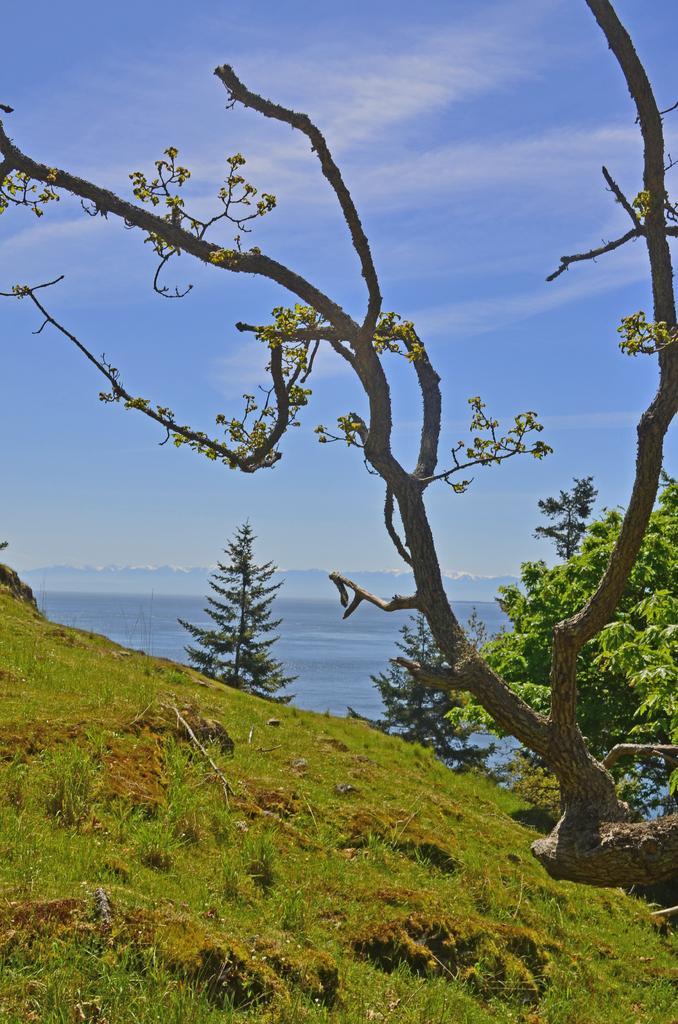In one or two sentences, can you explain what this image depicts? In this image there is grass on the hill. To the right there are trees. In the background there is the water. At the top there is the sky. 